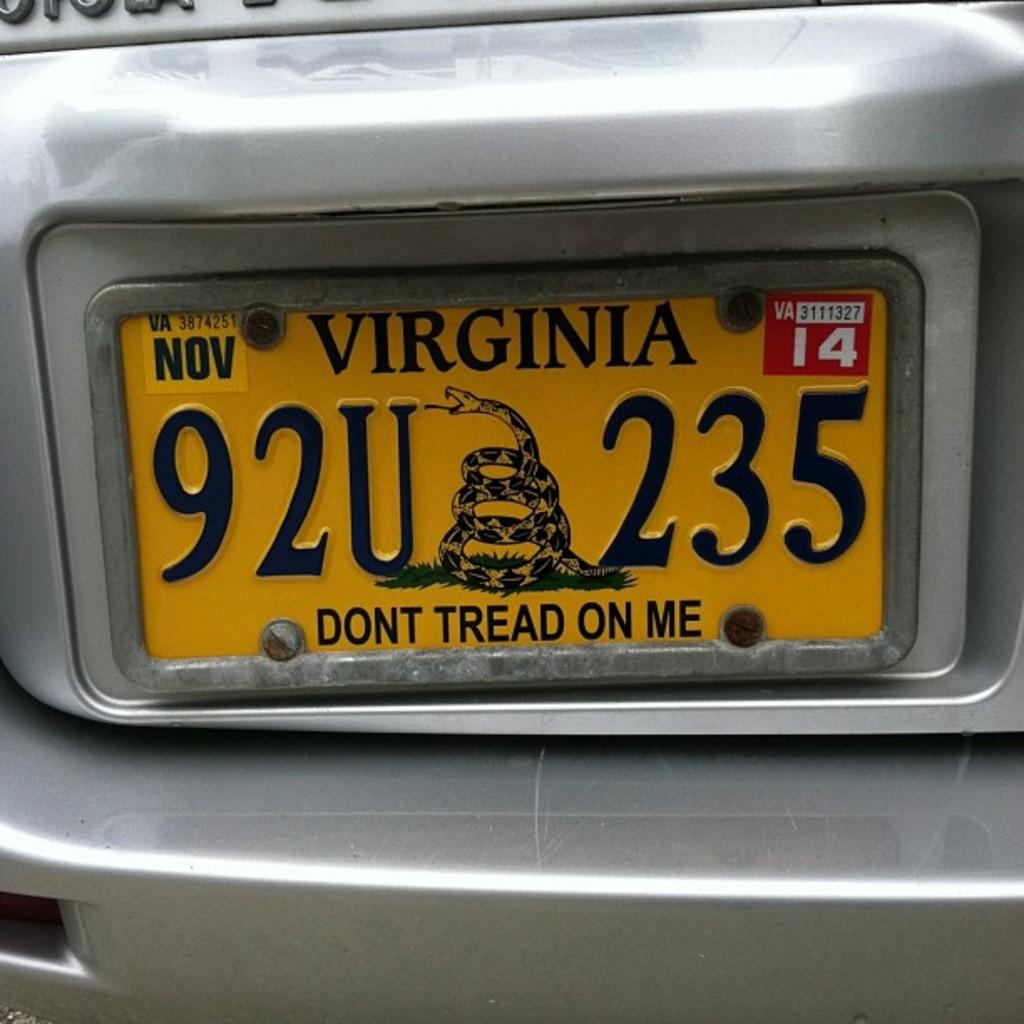<image>
Share a concise interpretation of the image provided. Yellow license plate which says 92U235 on it. 